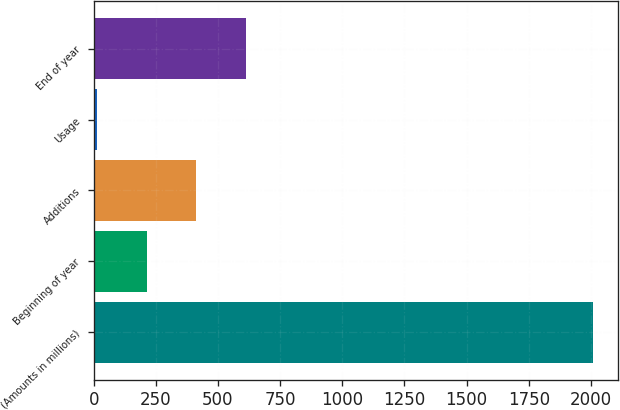<chart> <loc_0><loc_0><loc_500><loc_500><bar_chart><fcel>(Amounts in millions)<fcel>Beginning of year<fcel>Additions<fcel>Usage<fcel>End of year<nl><fcel>2010<fcel>213.06<fcel>412.72<fcel>13.4<fcel>612.38<nl></chart> 